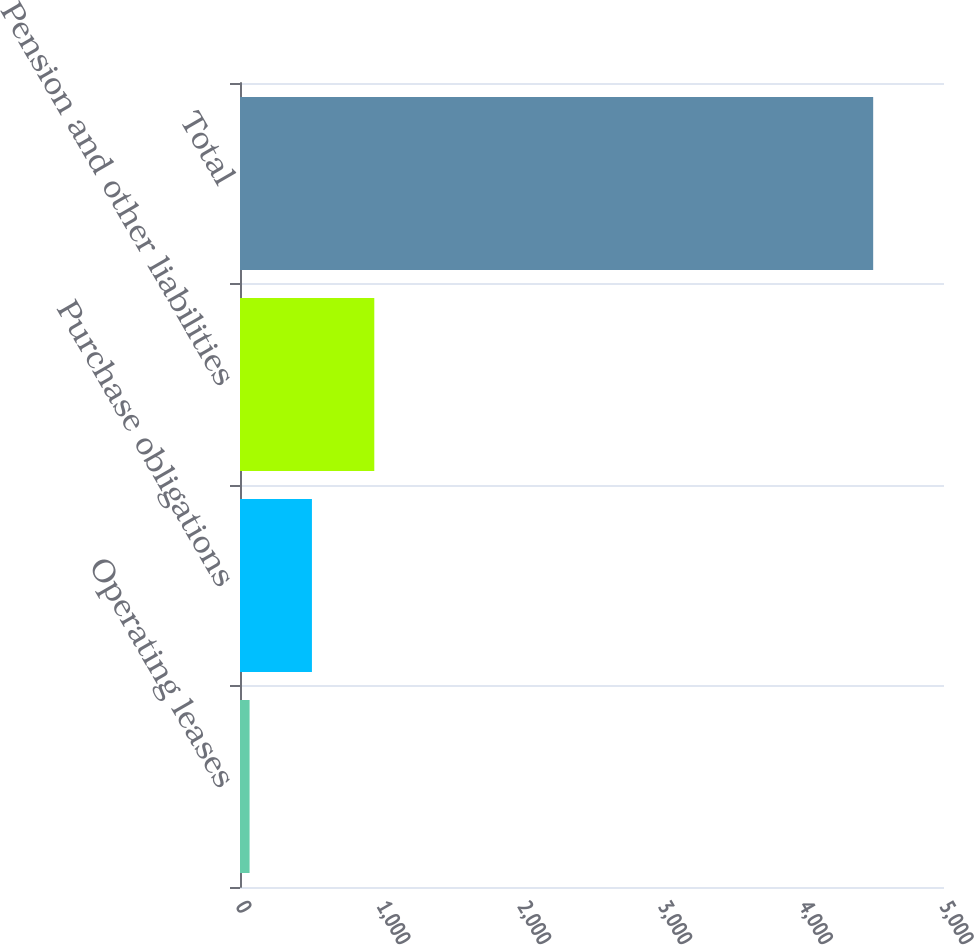Convert chart. <chart><loc_0><loc_0><loc_500><loc_500><bar_chart><fcel>Operating leases<fcel>Purchase obligations<fcel>Pension and other liabilities<fcel>Total<nl><fcel>68<fcel>510.9<fcel>953.8<fcel>4497<nl></chart> 